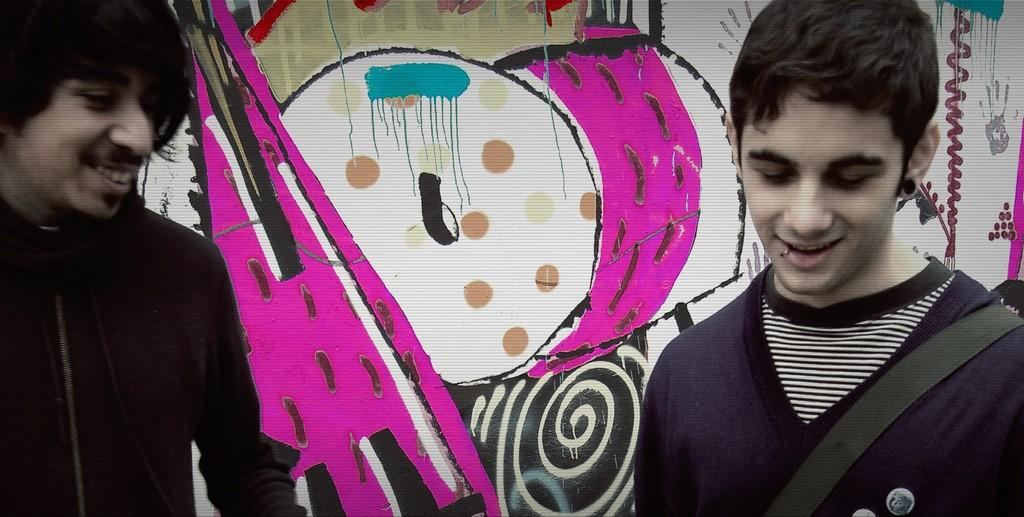How many people are in the image? There are two persons in the image. What expression do the persons have? The persons are smiling. What can be seen in the background of the image? There is a colorful wall in the background. What is on the colorful wall? There is a colorful painting on the wall. What type of tree is growing on the wall in the image? There is no tree present on the wall in the image; it features a colorful painting instead. 